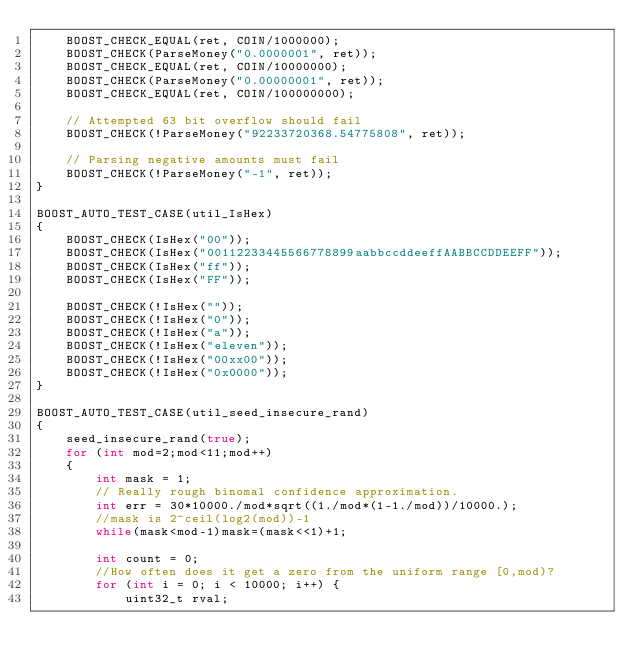Convert code to text. <code><loc_0><loc_0><loc_500><loc_500><_C++_>    BOOST_CHECK_EQUAL(ret, COIN/1000000);
    BOOST_CHECK(ParseMoney("0.0000001", ret));
    BOOST_CHECK_EQUAL(ret, COIN/10000000);
    BOOST_CHECK(ParseMoney("0.00000001", ret));
    BOOST_CHECK_EQUAL(ret, COIN/100000000);

    // Attempted 63 bit overflow should fail
    BOOST_CHECK(!ParseMoney("92233720368.54775808", ret));

    // Parsing negative amounts must fail
    BOOST_CHECK(!ParseMoney("-1", ret));
}

BOOST_AUTO_TEST_CASE(util_IsHex)
{
    BOOST_CHECK(IsHex("00"));
    BOOST_CHECK(IsHex("00112233445566778899aabbccddeeffAABBCCDDEEFF"));
    BOOST_CHECK(IsHex("ff"));
    BOOST_CHECK(IsHex("FF"));

    BOOST_CHECK(!IsHex(""));
    BOOST_CHECK(!IsHex("0"));
    BOOST_CHECK(!IsHex("a"));
    BOOST_CHECK(!IsHex("eleven"));
    BOOST_CHECK(!IsHex("00xx00"));
    BOOST_CHECK(!IsHex("0x0000"));
}

BOOST_AUTO_TEST_CASE(util_seed_insecure_rand)
{
    seed_insecure_rand(true);
    for (int mod=2;mod<11;mod++)
    {
        int mask = 1;
        // Really rough binomal confidence approximation.
        int err = 30*10000./mod*sqrt((1./mod*(1-1./mod))/10000.);
        //mask is 2^ceil(log2(mod))-1
        while(mask<mod-1)mask=(mask<<1)+1;

        int count = 0;
        //How often does it get a zero from the uniform range [0,mod)?
        for (int i = 0; i < 10000; i++) {
            uint32_t rval;</code> 